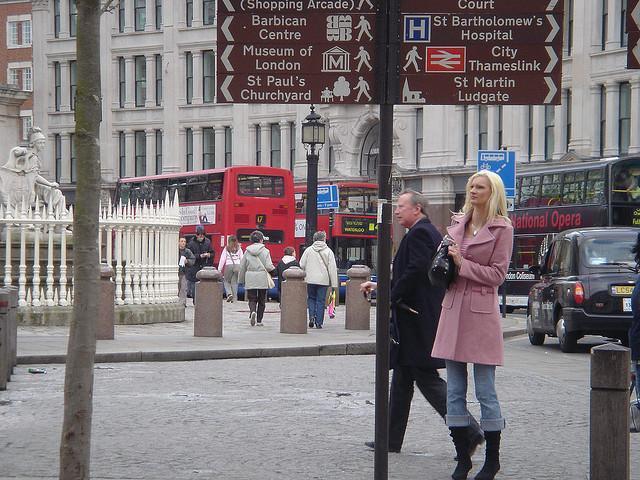How many people are visible?
Give a very brief answer. 4. How many buses are visible?
Give a very brief answer. 3. 